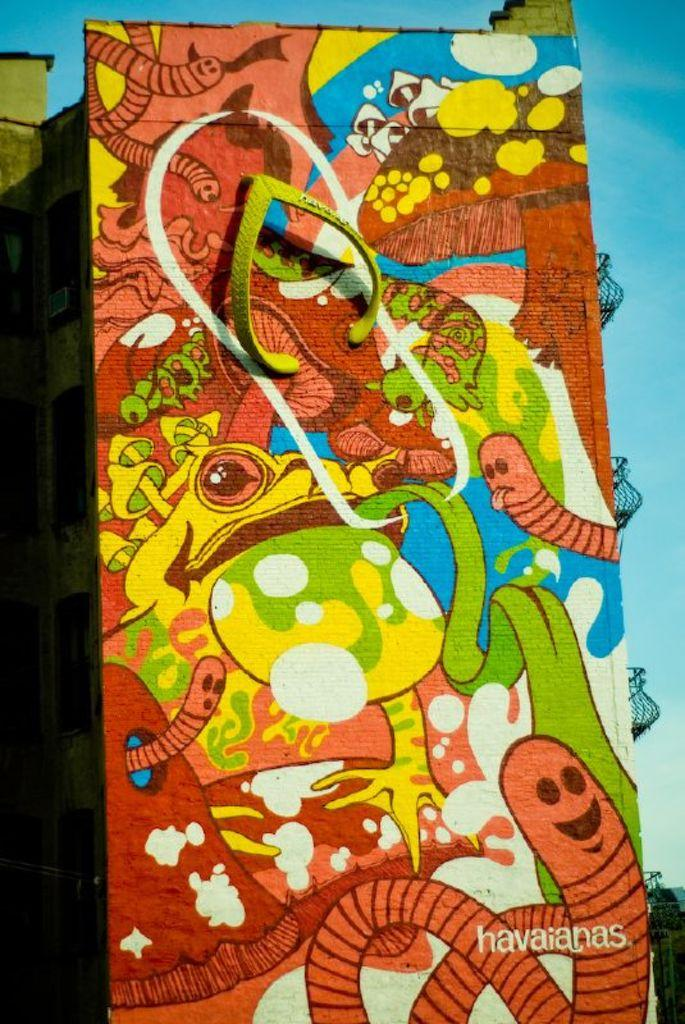<image>
Relay a brief, clear account of the picture shown. A color painting with a frog and worms by Havaianas. 